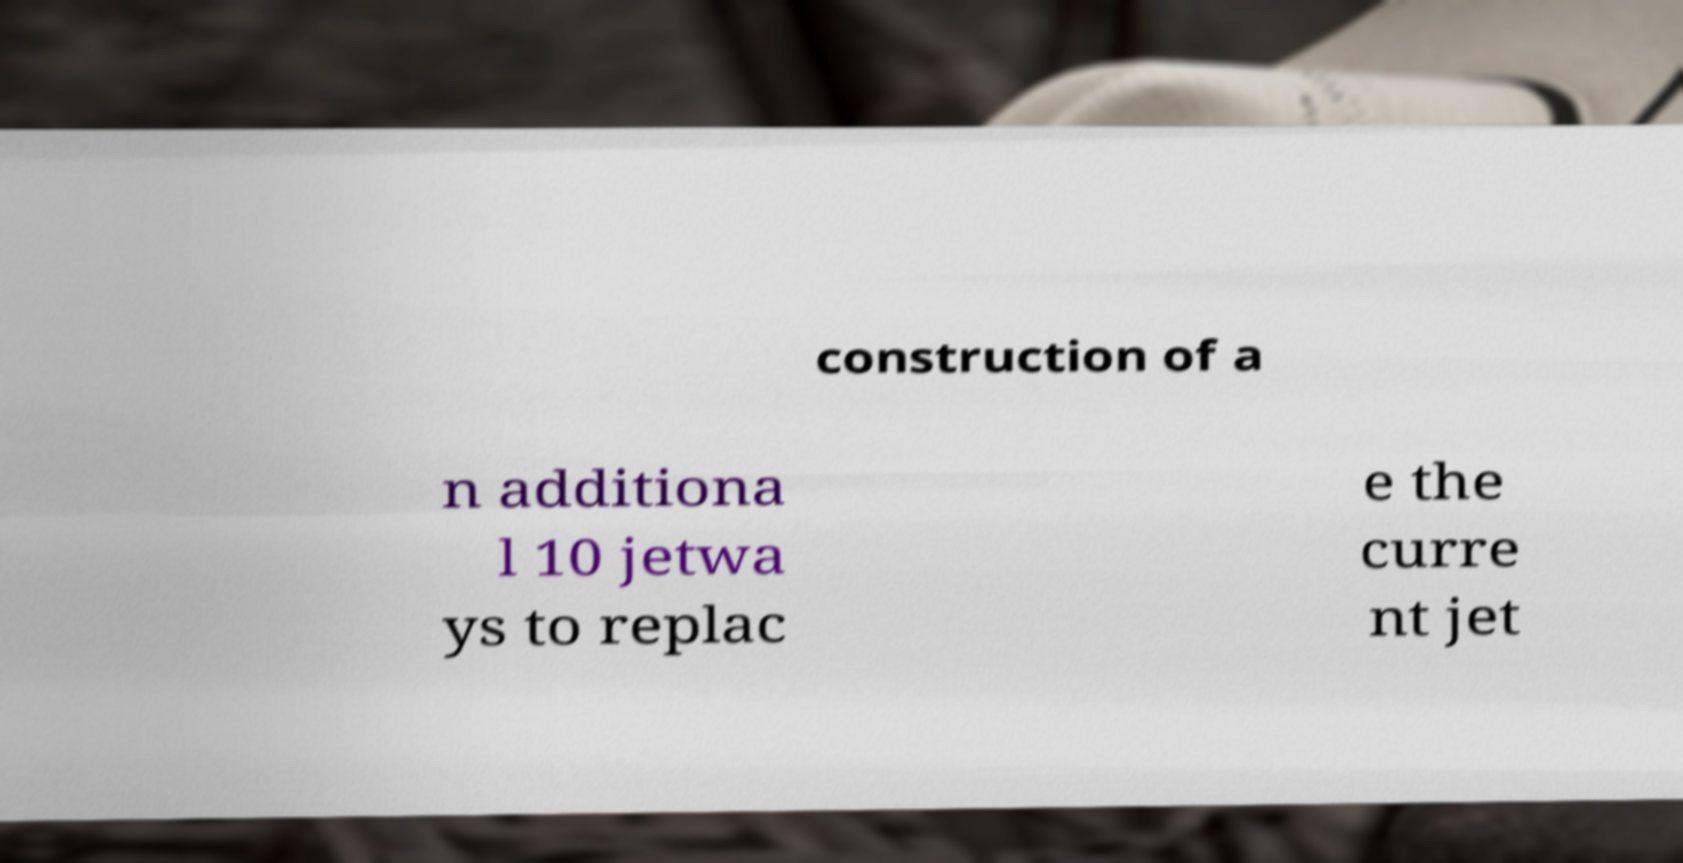For documentation purposes, I need the text within this image transcribed. Could you provide that? construction of a n additiona l 10 jetwa ys to replac e the curre nt jet 